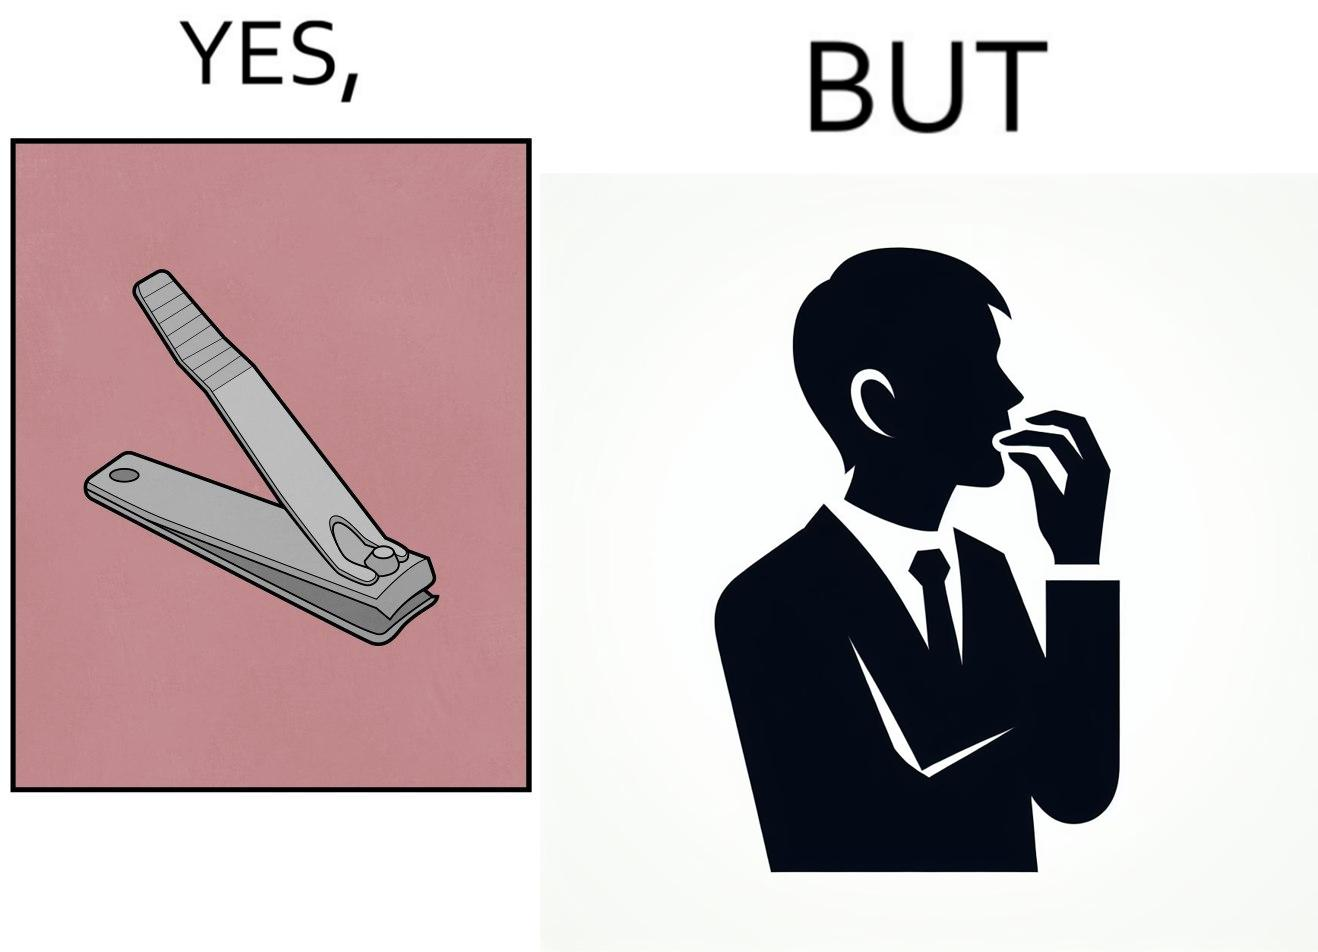What is shown in this image? The image is ironic, because even after nail clippers are available people prefer biting their nails by teeth 